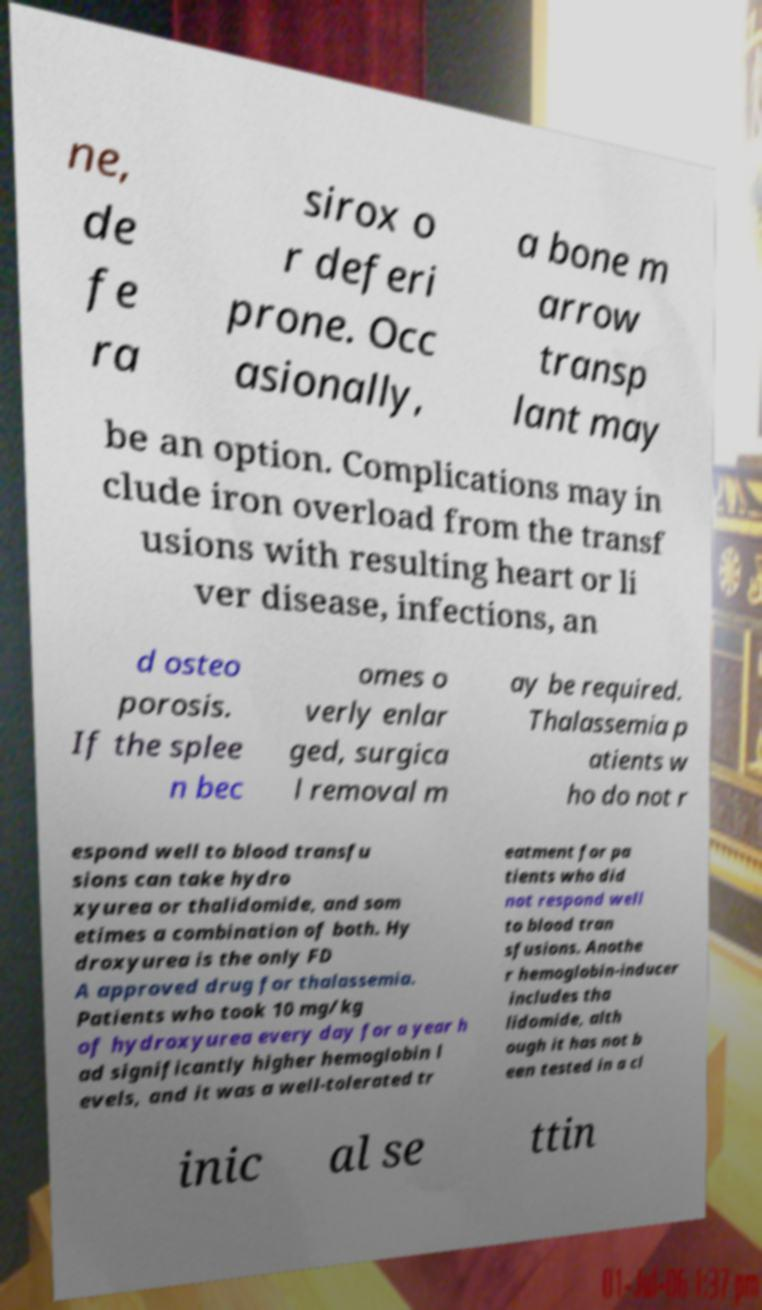Could you extract and type out the text from this image? ne, de fe ra sirox o r deferi prone. Occ asionally, a bone m arrow transp lant may be an option. Complications may in clude iron overload from the transf usions with resulting heart or li ver disease, infections, an d osteo porosis. If the splee n bec omes o verly enlar ged, surgica l removal m ay be required. Thalassemia p atients w ho do not r espond well to blood transfu sions can take hydro xyurea or thalidomide, and som etimes a combination of both. Hy droxyurea is the only FD A approved drug for thalassemia. Patients who took 10 mg/kg of hydroxyurea every day for a year h ad significantly higher hemoglobin l evels, and it was a well-tolerated tr eatment for pa tients who did not respond well to blood tran sfusions. Anothe r hemoglobin-inducer includes tha lidomide, alth ough it has not b een tested in a cl inic al se ttin 